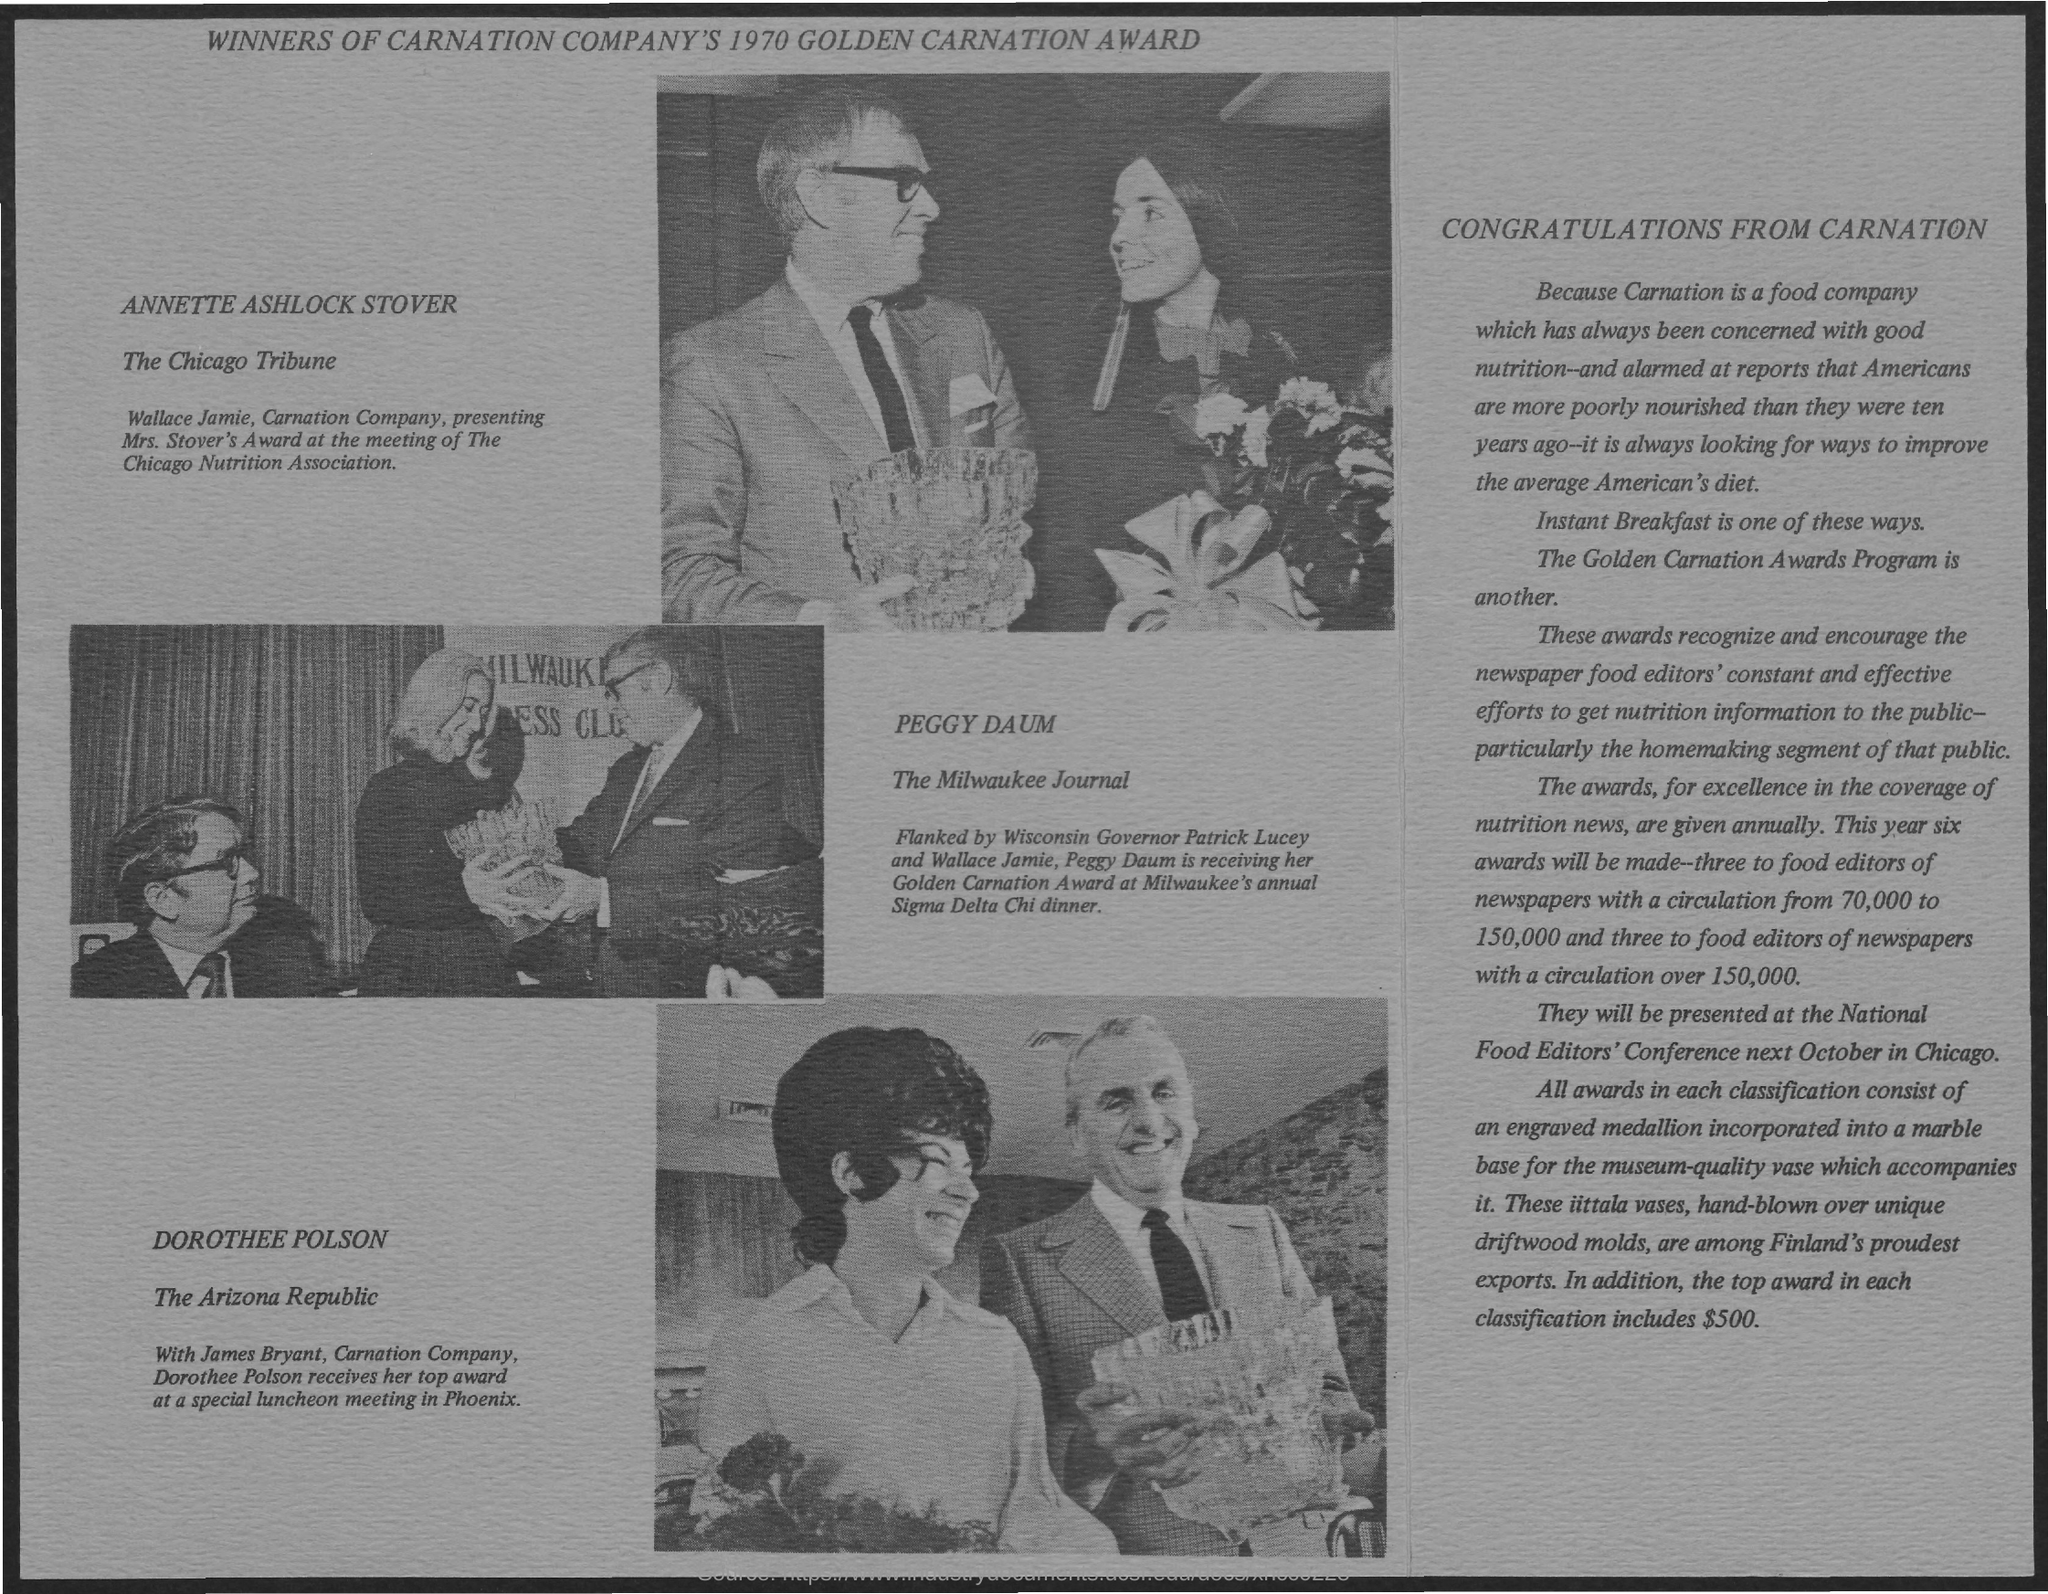Who is receiving Golden Carnation Award?
Your response must be concise. Peggy Daum. 